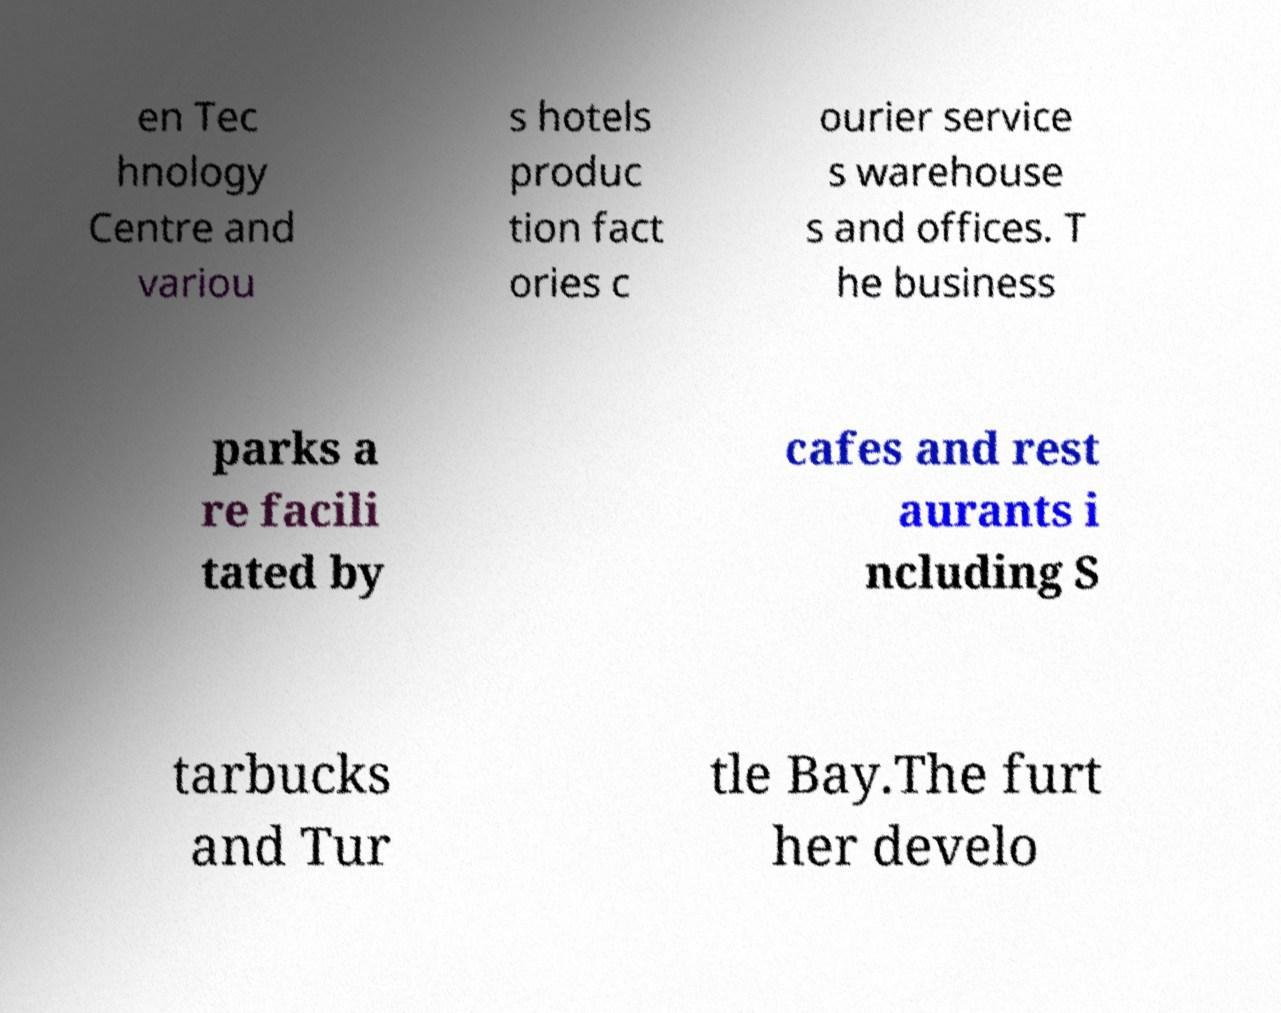What messages or text are displayed in this image? I need them in a readable, typed format. en Tec hnology Centre and variou s hotels produc tion fact ories c ourier service s warehouse s and offices. T he business parks a re facili tated by cafes and rest aurants i ncluding S tarbucks and Tur tle Bay.The furt her develo 